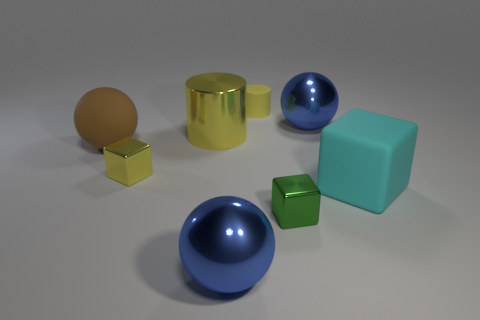There is a sphere that is on the right side of the big yellow thing and left of the small yellow cylinder; what is its color?
Offer a very short reply. Blue. What number of blue balls are the same size as the brown sphere?
Your answer should be very brief. 2. What is the size of the metal cube that is the same color as the big cylinder?
Make the answer very short. Small. There is a object that is both on the left side of the tiny green cube and behind the large shiny cylinder; what size is it?
Your answer should be compact. Small. There is a cylinder left of the blue metallic ball that is left of the yellow rubber object; what number of tiny rubber cylinders are on the left side of it?
Provide a succinct answer. 0. Is there a large matte ball that has the same color as the small matte object?
Keep it short and to the point. No. There is a metal cylinder that is the same size as the matte ball; what is its color?
Provide a succinct answer. Yellow. The large blue thing behind the tiny yellow thing that is left of the tiny yellow thing that is to the right of the big yellow metallic cylinder is what shape?
Offer a very short reply. Sphere. How many yellow cylinders are in front of the big rubber object that is on the left side of the tiny green metal object?
Make the answer very short. 0. There is a large rubber thing left of the small green shiny thing; does it have the same shape as the large blue object left of the small yellow cylinder?
Make the answer very short. Yes. 